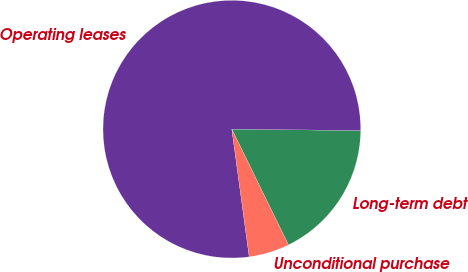Convert chart to OTSL. <chart><loc_0><loc_0><loc_500><loc_500><pie_chart><fcel>Long-term debt<fcel>Operating leases<fcel>Unconditional purchase<nl><fcel>17.59%<fcel>77.32%<fcel>5.09%<nl></chart> 